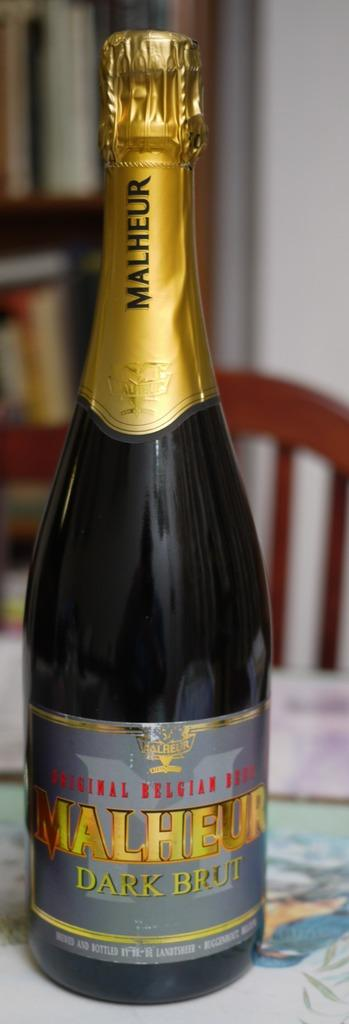Provide a one-sentence caption for the provided image. Malheur dark brut original Belgium beer sealed with foil. 